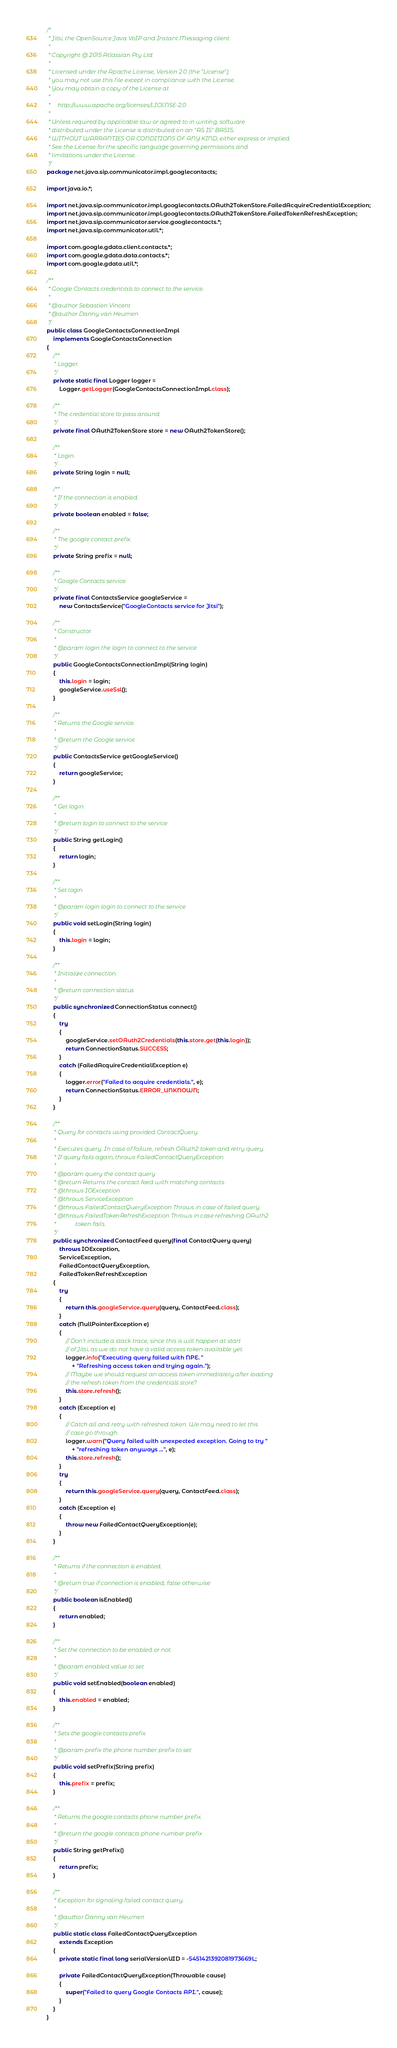<code> <loc_0><loc_0><loc_500><loc_500><_Java_>/*
 * Jitsi, the OpenSource Java VoIP and Instant Messaging client.
 *
 * Copyright @ 2015 Atlassian Pty Ltd
 *
 * Licensed under the Apache License, Version 2.0 (the "License");
 * you may not use this file except in compliance with the License.
 * You may obtain a copy of the License at
 *
 *     http://www.apache.org/licenses/LICENSE-2.0
 *
 * Unless required by applicable law or agreed to in writing, software
 * distributed under the License is distributed on an "AS IS" BASIS,
 * WITHOUT WARRANTIES OR CONDITIONS OF ANY KIND, either express or implied.
 * See the License for the specific language governing permissions and
 * limitations under the License.
 */
package net.java.sip.communicator.impl.googlecontacts;

import java.io.*;

import net.java.sip.communicator.impl.googlecontacts.OAuth2TokenStore.FailedAcquireCredentialException;
import net.java.sip.communicator.impl.googlecontacts.OAuth2TokenStore.FailedTokenRefreshException;
import net.java.sip.communicator.service.googlecontacts.*;
import net.java.sip.communicator.util.*;

import com.google.gdata.client.contacts.*;
import com.google.gdata.data.contacts.*;
import com.google.gdata.util.*;

/**
 * Google Contacts credentials to connect to the service.
 *
 * @author Sebastien Vincent
 * @author Danny van Heumen
 */
public class GoogleContactsConnectionImpl
    implements GoogleContactsConnection
{
    /**
     * Logger.
     */
    private static final Logger logger =
        Logger.getLogger(GoogleContactsConnectionImpl.class);

    /**
     * The credential store to pass around.
     */
    private final OAuth2TokenStore store = new OAuth2TokenStore();

    /**
     * Login.
     */
    private String login = null;

    /**
     * If the connection is enabled.
     */
    private boolean enabled = false;

    /**
     * The google contact prefix.
     */
    private String prefix = null;

    /**
     * Google Contacts service.
     */
    private final ContactsService googleService =
        new ContactsService("GoogleContacts service for Jitsi");

    /**
     * Constructor.
     *
     * @param login the login to connect to the service
     */
    public GoogleContactsConnectionImpl(String login)
    {
        this.login = login;
        googleService.useSsl();
    }

    /**
     * Returns the Google service.
     *
     * @return the Google service
     */
    public ContactsService getGoogleService()
    {
        return googleService;
    }

    /**
     * Get login.
     *
     * @return login to connect to the service
     */
    public String getLogin()
    {
        return login;
    }

    /**
     * Set login.
     *
     * @param login login to connect to the service
     */
    public void setLogin(String login)
    {
        this.login = login;
    }

    /**
     * Initialize connection.
     *
     * @return connection status
     */
    public synchronized ConnectionStatus connect()
    {
        try
        {
            googleService.setOAuth2Credentials(this.store.get(this.login));
            return ConnectionStatus.SUCCESS;
        }
        catch (FailedAcquireCredentialException e)
        {
            logger.error("Failed to acquire credentials.", e);
            return ConnectionStatus.ERROR_UNKNOWN;
        }
    }

    /**
     * Query for contacts using provided ContactQuery.
     *
     * Executes query. In case of failure, refresh OAuth2 token and retry query.
     * If query fails again, throws FailedContactQueryException.
     *
     * @param query the contact query
     * @return Returns the contact feed with matching contacts.
     * @throws IOException
     * @throws ServiceException
     * @throws FailedContactQueryException Throws in case of failed query.
     * @throws FailedTokenRefreshException Throws in case refreshing OAuth2
     *             token fails.
     */
    public synchronized ContactFeed query(final ContactQuery query)
        throws IOException,
        ServiceException,
        FailedContactQueryException,
        FailedTokenRefreshException
    {
        try
        {
            return this.googleService.query(query, ContactFeed.class);
        }
        catch (NullPointerException e)
        {
            // Don't include a stack trace, since this is will happen at start
            // of Jitsi, as we do not have a valid access token available yet.
            logger.info("Executing query failed with NPE. "
                + "Refreshing access token and trying again.");
            // Maybe we should request an access token immediately after loading
            // the refresh token from the credentials store?
            this.store.refresh();
        }
        catch (Exception e)
        {
            // Catch all and retry with refreshed token. We may need to let this
            // case go through.
            logger.warn("Query failed with unexpected exception. Going to try "
                + "refreshing token anyways ...", e);
            this.store.refresh();
        }
        try
        {
            return this.googleService.query(query, ContactFeed.class);
        }
        catch (Exception e)
        {
            throw new FailedContactQueryException(e);
        }
    }

    /**
     * Returns if the connection is enabled.
     *
     * @return true if connection is enabled, false otherwise
     */
    public boolean isEnabled()
    {
        return enabled;
    }

    /**
     * Set the connection to be enabled or not.
     *
     * @param enabled value to set
     */
    public void setEnabled(boolean enabled)
    {
        this.enabled = enabled;
    }

    /**
     * Sets the google contacts prefix.
     *
     * @param prefix the phone number prefix to set
     */
    public void setPrefix(String prefix)
    {
        this.prefix = prefix;
    }

    /**
     * Returns the google contacts phone number prefix.
     *
     * @return the google contacts phone number prefix
     */
    public String getPrefix()
    {
        return prefix;
    }

    /**
     * Exception for signaling failed contact query.
     *
     * @author Danny van Heumen
     */
    public static class FailedContactQueryException
        extends Exception
    {
        private static final long serialVersionUID = -5451421392081973669L;

        private FailedContactQueryException(Throwable cause)
        {
            super("Failed to query Google Contacts API.", cause);
        }
    }
}
</code> 